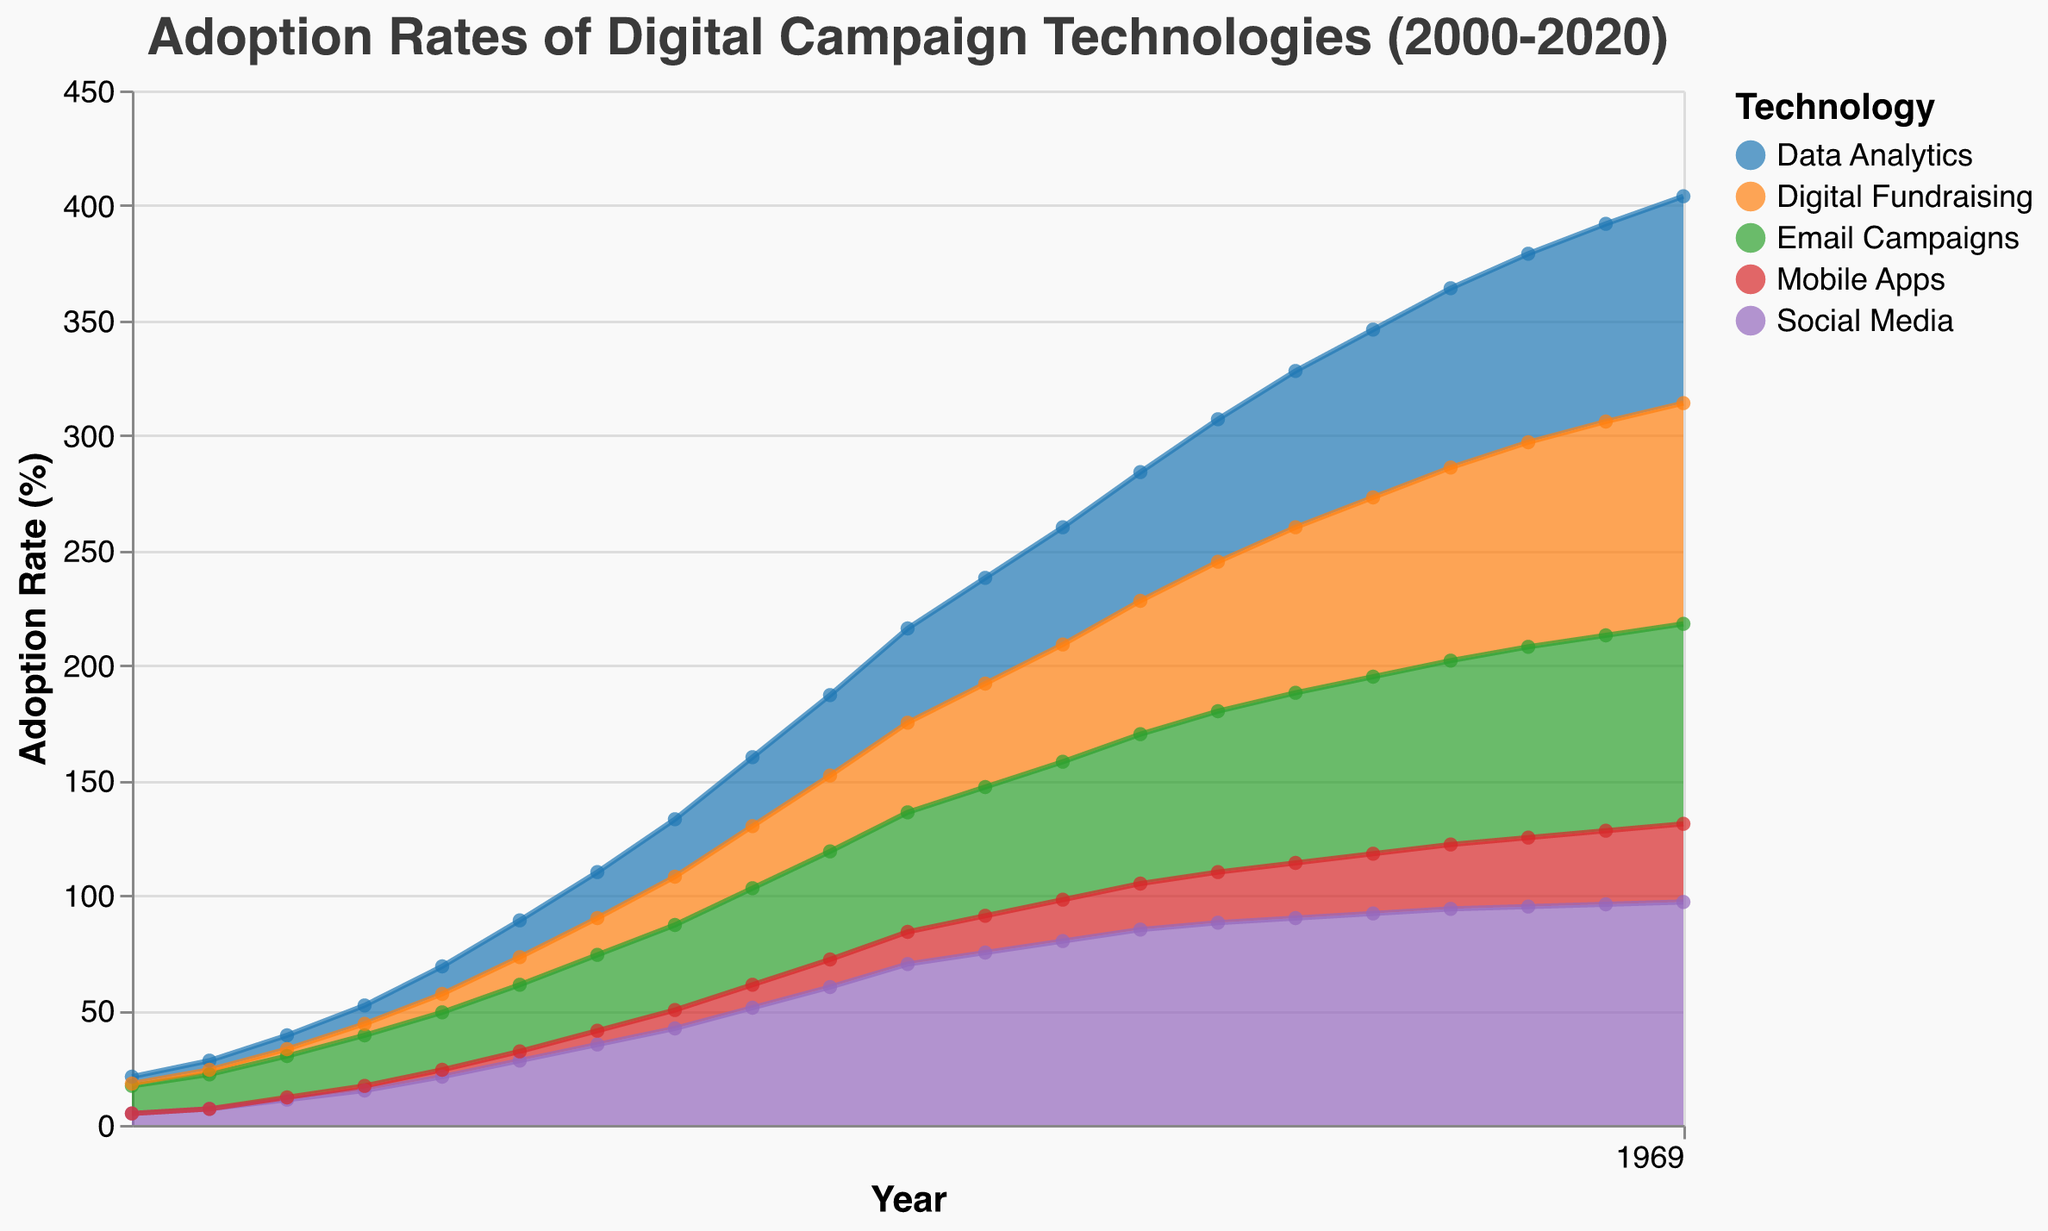What is the title of the figure? The title of the figure is usually located at the top center. In this case, it reads "Adoption Rates of Digital Campaign Technologies (2000-2020)".
Answer: "Adoption Rates of Digital Campaign Technologies (2000-2020)" What are the technologies listed in the legend? The legend shows the colors representing different technologies. Here, it includes Social Media, Email Campaigns, Data Analytics, Digital Fundraising, and Mobile Apps.
Answer: Social Media, Email Campaigns, Data Analytics, Digital Fundraising, Mobile Apps In what year did the adoption rate of Social Media surpass 50%? Looking at the Social Media area, it surpasses the 50% mark in 2008, as the trend is going upwards and it crosses the 50% line in this year.
Answer: 2008 Which technology had the lowest adoption rate in 2010? By observing the 2010 vertical line and checking the y-values for each segment, Mobile Apps has the lowest adoption rate, only reaching up to 14%.
Answer: Mobile Apps Between 2015 and 2020, which technology saw the highest increase in adoption rate? Comparing the values from 2015 to 2020 for all technologies, Digital Fundraising increased from 72% to 96%, an increase of 24 percentage points, which is the highest.
Answer: Digital Fundraising How many years did it take for Data Analytics to reach an adoption rate of 50% or more? Data Analytics first reaches 51% in 2012. It started at 3% in 2000, so it took 12 years to reach at least 50%.
Answer: 12 years Which two technologies have the closest adoption rates in 2015? In 2015, Data Analytics and Email Campaigns have very close adoption rates, 68% and 74% respectively, making a difference of 6 percentage points.
Answer: Data Analytics and Email Campaigns What was the adoption rate of Mobile Apps in 2005? Finding 2005 and checking the Mobile Apps portion of the area chart shows the adoption rate as 4%.
Answer: 4% Did the adoption rate of any technology decline at any point between 2000 and 2020? Observing the trends for all technologies, none of the adoption rates show a downward trend; all are increasing incrementally.
Answer: No 